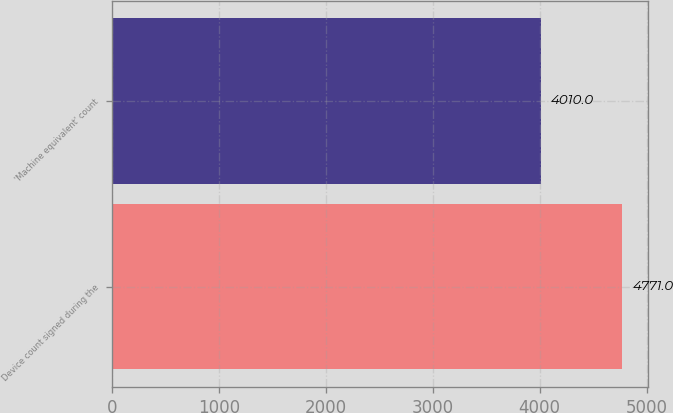Convert chart. <chart><loc_0><loc_0><loc_500><loc_500><bar_chart><fcel>Device count signed during the<fcel>'Machine equivalent' count<nl><fcel>4771<fcel>4010<nl></chart> 